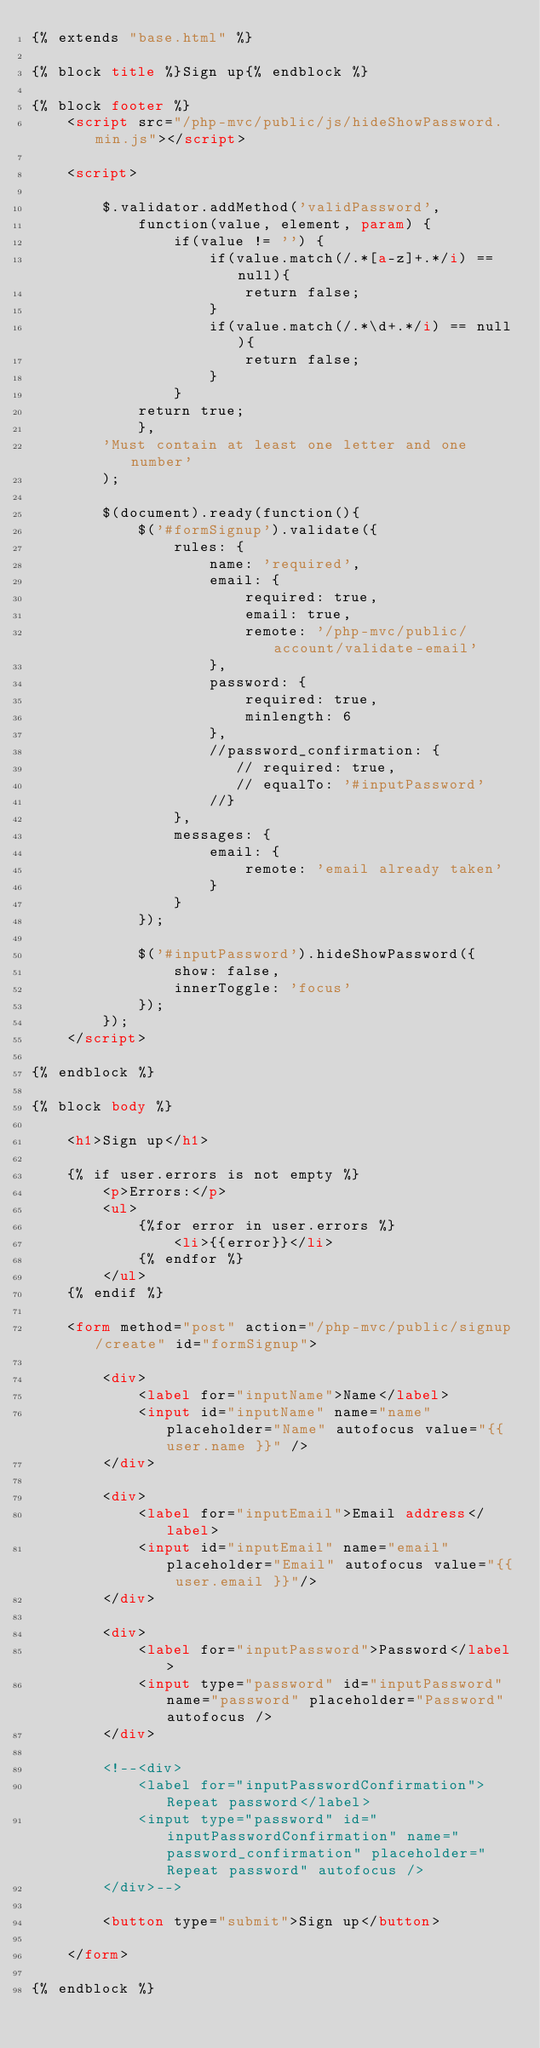<code> <loc_0><loc_0><loc_500><loc_500><_HTML_>{% extends "base.html" %}

{% block title %}Sign up{% endblock %}

{% block footer %}
    <script src="/php-mvc/public/js/hideShowPassword.min.js"></script>

    <script> 

        $.validator.addMethod('validPassword',
            function(value, element, param) {
                if(value != '') {
                    if(value.match(/.*[a-z]+.*/i) == null){
                        return false;
                    }
                    if(value.match(/.*\d+.*/i) == null){
                        return false;
                    }
                }
            return true;
            },
        'Must contain at least one letter and one number'
        );

        $(document).ready(function(){
            $('#formSignup').validate({
                rules: {
                    name: 'required',
                    email: {
                        required: true,
                        email: true,
                        remote: '/php-mvc/public/account/validate-email'
                    },
                    password: {
                        required: true,
                        minlength: 6
                    },
                    //password_confirmation: {
                       // required: true,
                       // equalTo: '#inputPassword'
                    //}
                },
                messages: {
                    email: {
                        remote: 'email already taken'
                    }
                }
            });

            $('#inputPassword').hideShowPassword({
                show: false,
                innerToggle: 'focus'
            });
        });
    </script>

{% endblock %}

{% block body %}

    <h1>Sign up</h1>

    {% if user.errors is not empty %}
        <p>Errors:</p>
        <ul>
            {%for error in user.errors %}
                <li>{{error}}</li>
            {% endfor %}
        </ul>
    {% endif %}

    <form method="post" action="/php-mvc/public/signup/create" id="formSignup">

        <div>
            <label for="inputName">Name</label>
            <input id="inputName" name="name" placeholder="Name" autofocus value="{{ user.name }}" />
        </div>

        <div>
            <label for="inputEmail">Email address</label>
            <input id="inputEmail" name="email" placeholder="Email" autofocus value="{{ user.email }}"/>
        </div>

        <div>
            <label for="inputPassword">Password</label>
            <input type="password" id="inputPassword" name="password" placeholder="Password" autofocus />
        </div>

        <!--<div>
            <label for="inputPasswordConfirmation">Repeat password</label>
            <input type="password" id="inputPasswordConfirmation" name="password_confirmation" placeholder="Repeat password" autofocus />
        </div>-->

        <button type="submit">Sign up</button>

    </form>

{% endblock %}
</code> 